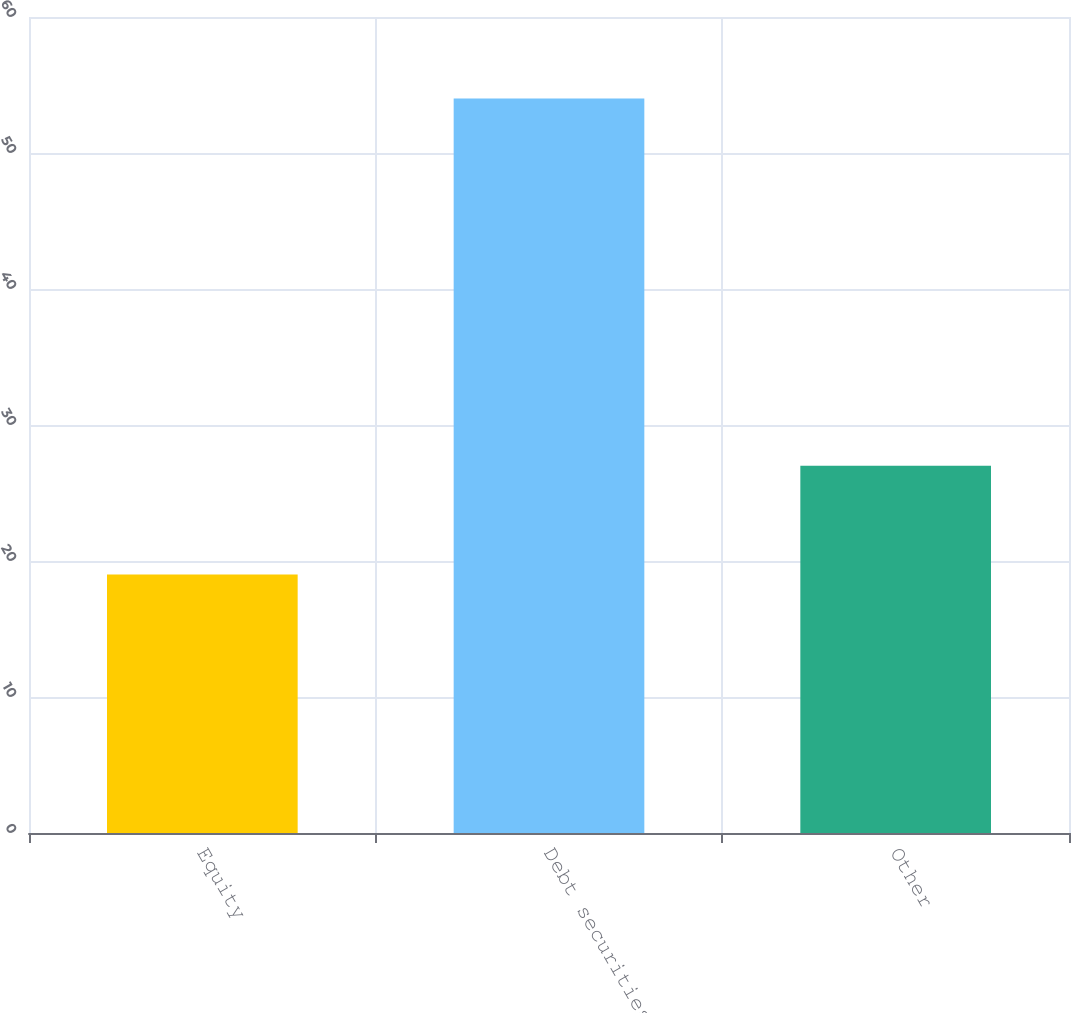Convert chart. <chart><loc_0><loc_0><loc_500><loc_500><bar_chart><fcel>Equity<fcel>Debt securities<fcel>Other<nl><fcel>19<fcel>54<fcel>27<nl></chart> 